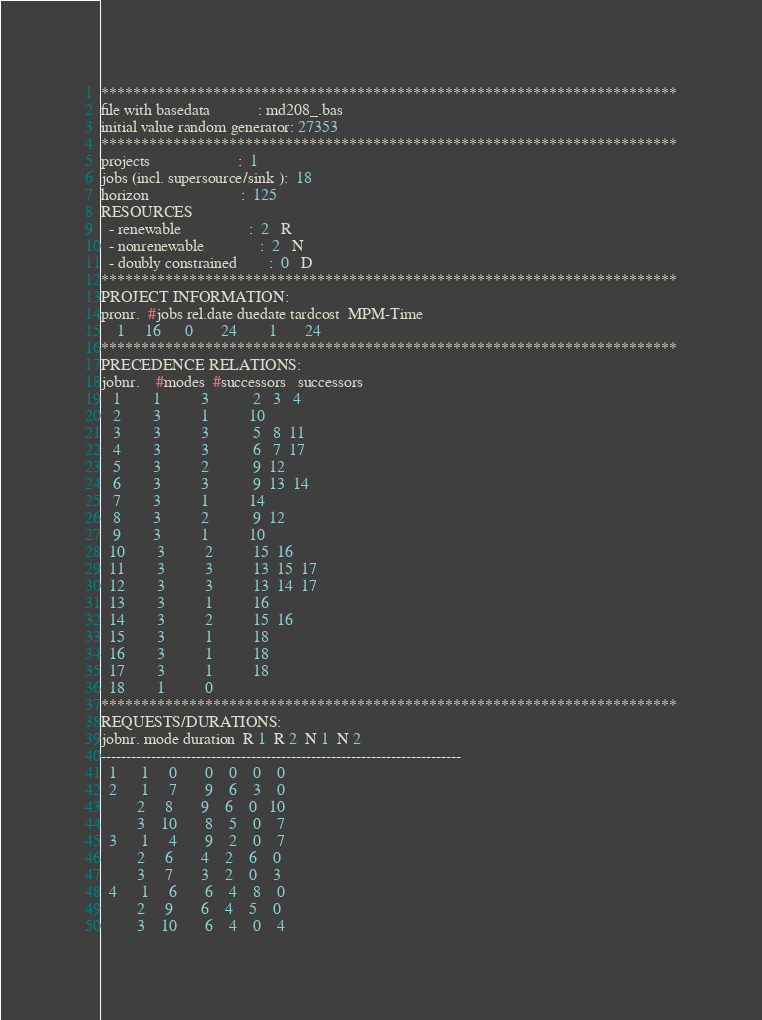Convert code to text. <code><loc_0><loc_0><loc_500><loc_500><_ObjectiveC_>************************************************************************
file with basedata            : md208_.bas
initial value random generator: 27353
************************************************************************
projects                      :  1
jobs (incl. supersource/sink ):  18
horizon                       :  125
RESOURCES
  - renewable                 :  2   R
  - nonrenewable              :  2   N
  - doubly constrained        :  0   D
************************************************************************
PROJECT INFORMATION:
pronr.  #jobs rel.date duedate tardcost  MPM-Time
    1     16      0       24        1       24
************************************************************************
PRECEDENCE RELATIONS:
jobnr.    #modes  #successors   successors
   1        1          3           2   3   4
   2        3          1          10
   3        3          3           5   8  11
   4        3          3           6   7  17
   5        3          2           9  12
   6        3          3           9  13  14
   7        3          1          14
   8        3          2           9  12
   9        3          1          10
  10        3          2          15  16
  11        3          3          13  15  17
  12        3          3          13  14  17
  13        3          1          16
  14        3          2          15  16
  15        3          1          18
  16        3          1          18
  17        3          1          18
  18        1          0        
************************************************************************
REQUESTS/DURATIONS:
jobnr. mode duration  R 1  R 2  N 1  N 2
------------------------------------------------------------------------
  1      1     0       0    0    0    0
  2      1     7       9    6    3    0
         2     8       9    6    0   10
         3    10       8    5    0    7
  3      1     4       9    2    0    7
         2     6       4    2    6    0
         3     7       3    2    0    3
  4      1     6       6    4    8    0
         2     9       6    4    5    0
         3    10       6    4    0    4</code> 